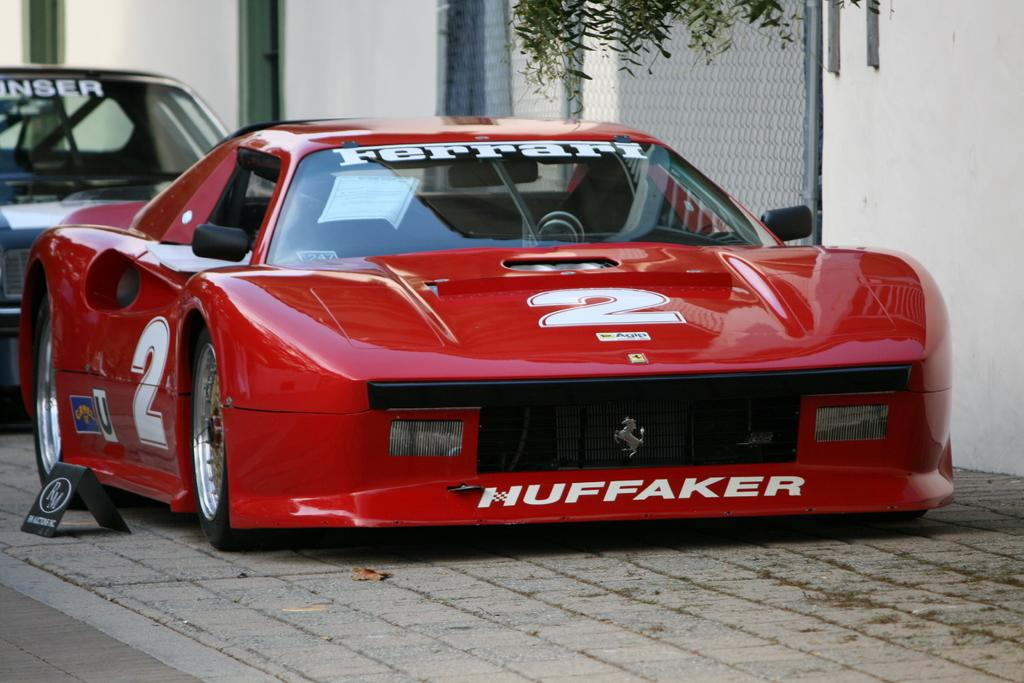How many cars are parked in the image? There are two cars parked on the ground in the image. What is located beside the cars? There is a board beside the cars. What can be seen on the backside of the image? Leaves, a metal fence, poles, and a wall are visible on the backside of the image. What type of grape is being used to decorate the cars in the image? There are no grapes present in the image, and the cars are not being decorated with any fruits. 